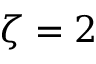Convert formula to latex. <formula><loc_0><loc_0><loc_500><loc_500>\zeta = 2</formula> 